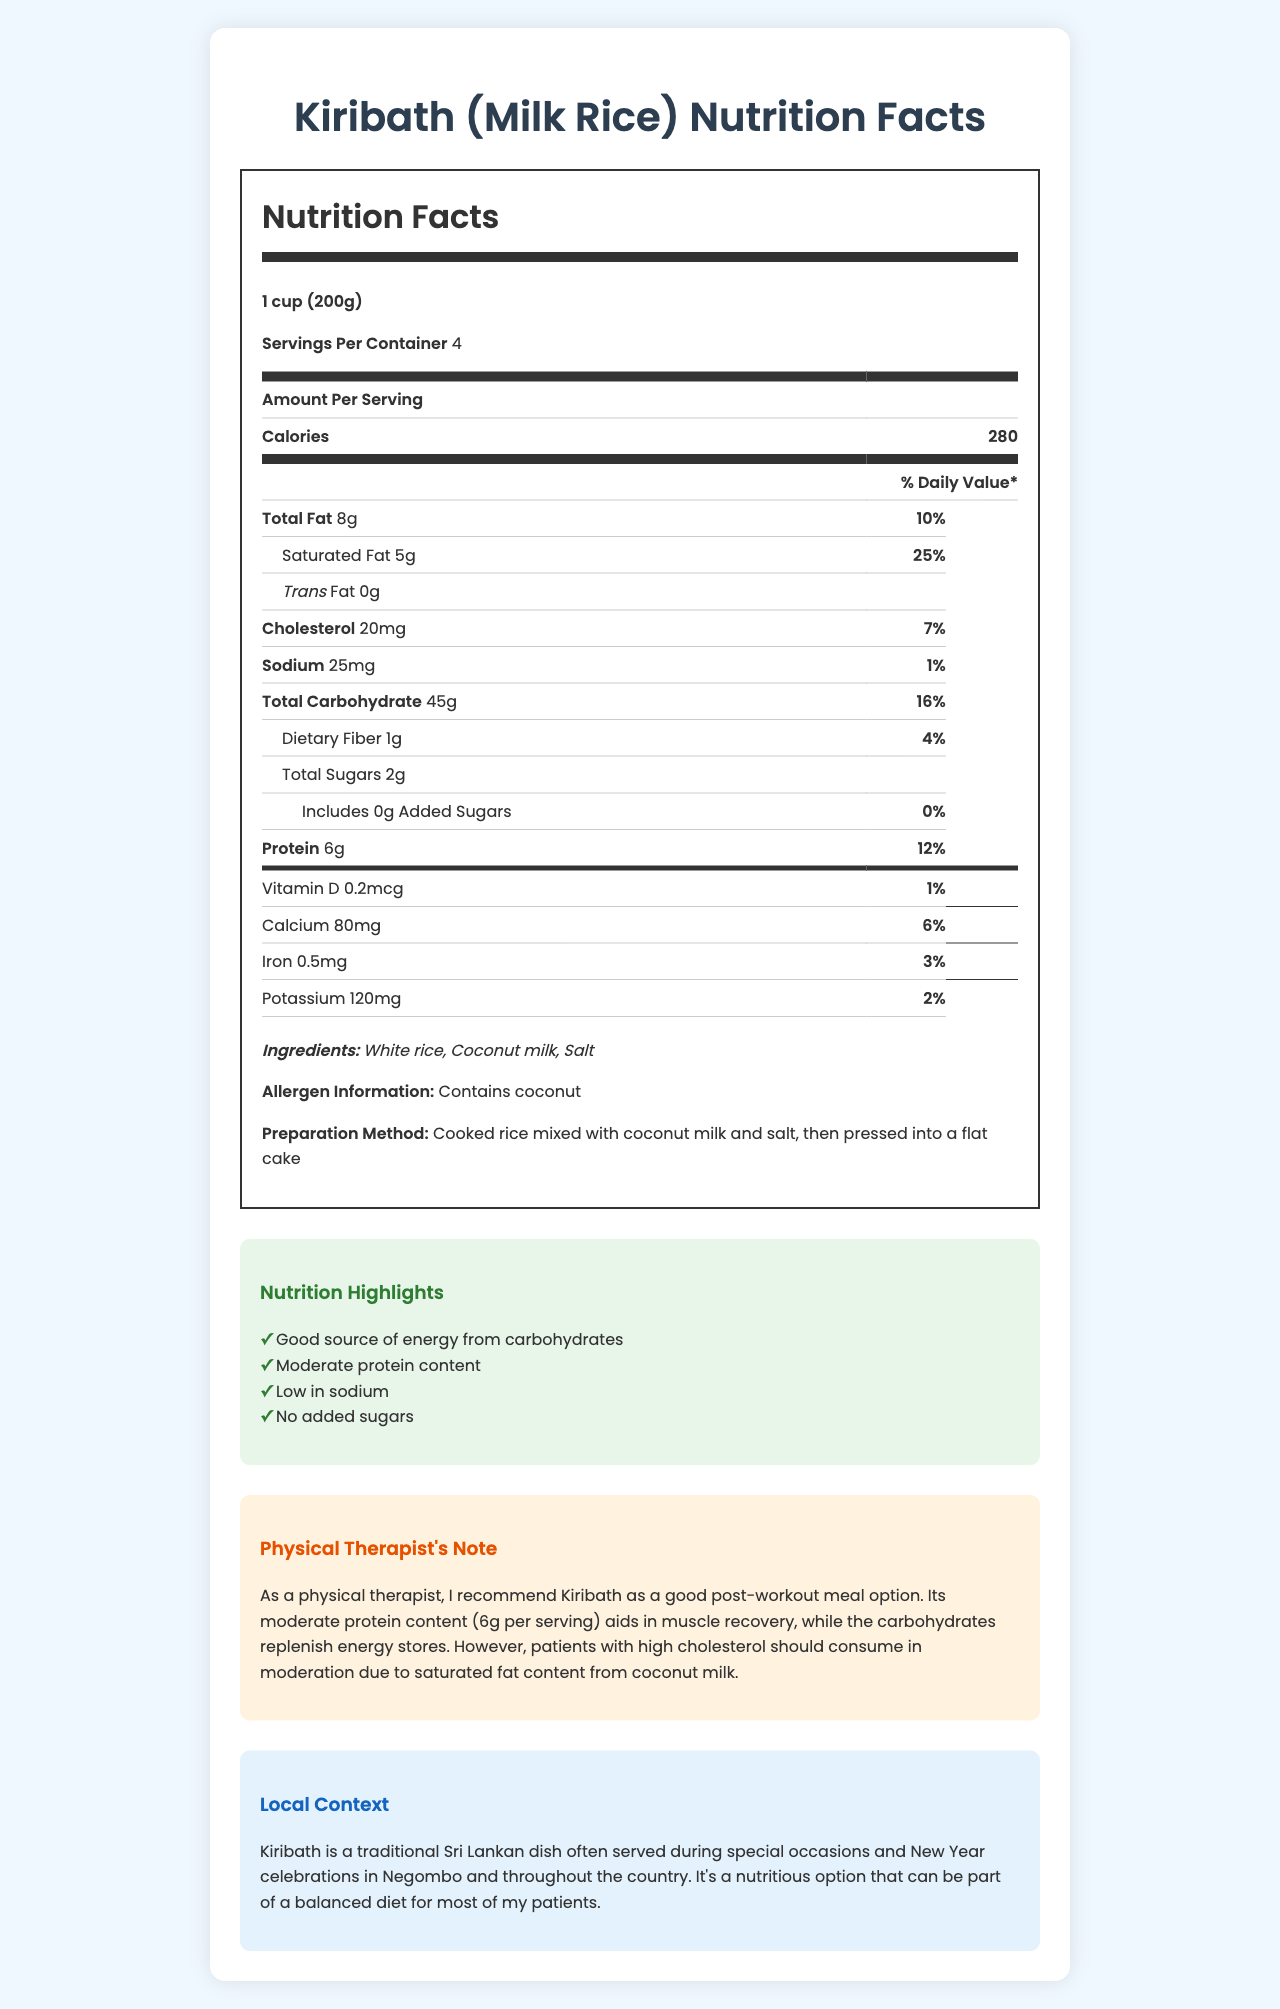what is the serving size stated for Kiribath? The serving size of Kiribath is specified as 1 cup (200g), which is directly stated under the "Nutrition Facts" section.
Answer: 1 cup (200g) how many grams of protein are in one serving of Kiribath? The protein content per serving is explicitly mentioned under the "Protein" section in the Nutrition Facts.
Answer: 6g what allergen is listed in the document? The allergen information notes that the dish contains coconut.
Answer: Coconut how much saturated fat is in one serving of Kiribath? The saturated fat content of 5g per serving is located under the "Saturated Fat" sub-section of the Nutrition Facts.
Answer: 5g what is the amount of calcium in one serving of Kiribath? The amount of calcium is listed as 80mg in the Vitamins and Minerals section.
Answer: 80mg what is the purpose of serving Kiribath as a post-workout meal according to the physical therapist's note? The Physical Therapist's Note mentions that Kiribath's moderate protein content aids in muscle recovery, and its carbohydrates help replenish energy stores.
Answer: Aids in muscle recovery and replenishes energy what are the main ingredients of Kiribath? A. White rice, Coconut milk, Salt B. Brown rice, Coconut water, Sugar C. White rice, Cashew milk, Olive oil D. Basmati rice, Coconut cream, Salt The main ingredients listed are White rice, Coconut milk, and Salt.
Answer: A. White rice, Coconut milk, Salt which aspect should patients with high cholesterol be cautious about? A. Sodium content B. Saturated fat content C. Protein content D. Vitamin D content The therapist note advises caution with saturated fat for patients with high cholesterol.
Answer: B. Saturated fat content what is the daily value percentage of protein in Kiribath per serving? The daily value percentage for protein is stated to be 12% in the Nutrition Facts table.
Answer: 12% how often is Kiribath served in Sri Lankan culture? According to the local context section, Kiribath is often served during special occasions and New Year celebrations.
Answer: Special occasions and New Year celebrations can you determine how long it takes to prepare Kiribath from the document? The document provides details about preparation methods but does not mention the time required to prepare Kiribath.
Answer: Not enough information is there any trans fat in Kiribath? The Nutrition Facts label specifies that there is 0g of trans fat per serving.
Answer: No summarize the document. The document contains not just the nutritional breakdown of Kiribath but also cultural context, preparation details, allergen information, and personalized health advice, making it a holistic overview of the dish.
Answer: The document provides comprehensive Nutrition Facts and additional information about Kiribath (Milk Rice), a traditional Sri Lankan rice dish. It details the serving size, calories, fat, cholesterol, sodium, carbohydrates, fiber, sugars, protein, and vitamins & minerals content per serving. The document highlights the dish's ingredients, allergens, preparation method, and nutritional benefits. A physical therapist's note recommends it as a good post-workout meal due to its protein and carbohydrate content, with caution advised for high cholesterol patients because of saturated fat. Kiribath is commonly served during special occasions in Sri Lanka. 